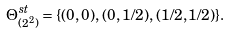<formula> <loc_0><loc_0><loc_500><loc_500>\Theta _ { ( 2 ^ { 2 } ) } ^ { s t } = \{ ( 0 , 0 ) , \, ( 0 , 1 / 2 ) , \, ( 1 / 2 , 1 / 2 ) \} .</formula> 